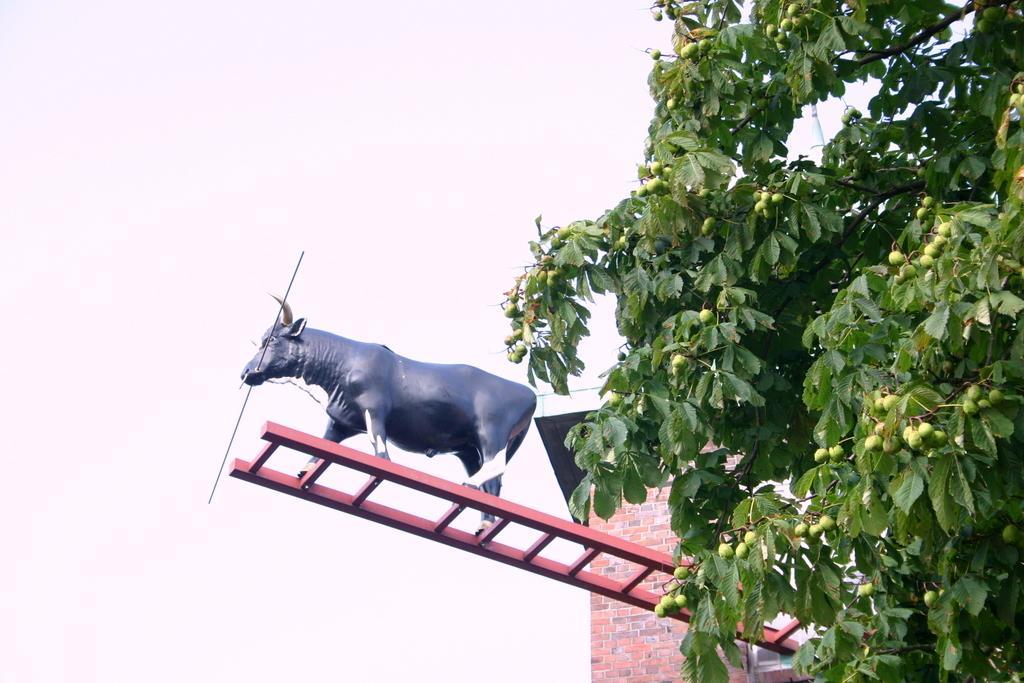Please provide a concise description of this image. In this picture we can see a statue of an animal on a ladder and in the background we can see the sky. 